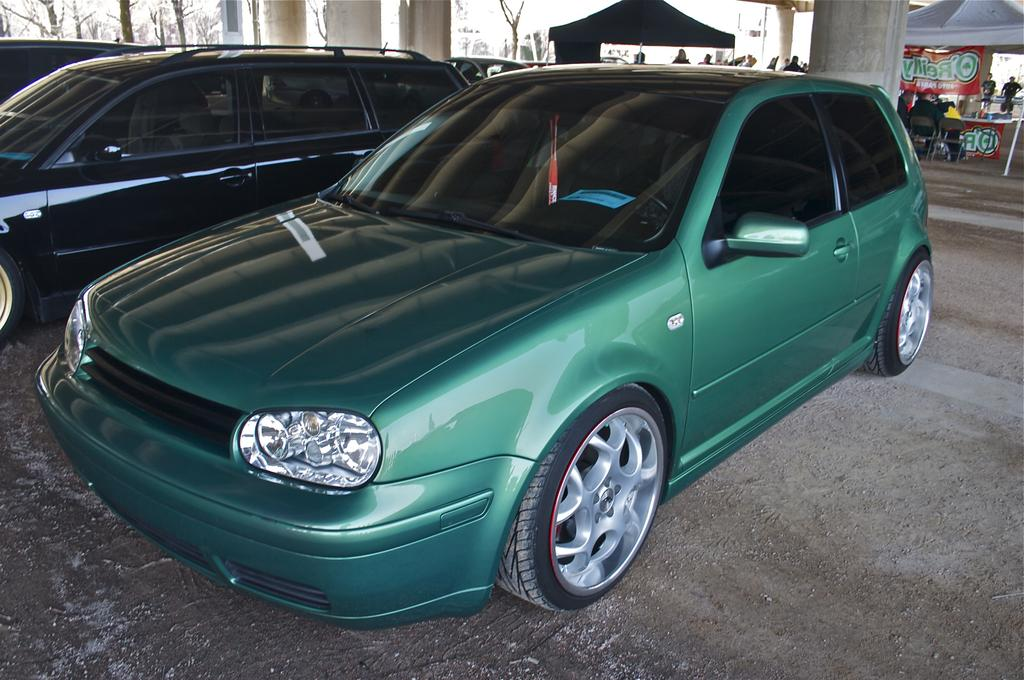What can be seen in the background of the image? In the background of the image, there are cars and tents. What are the people in the tents doing? The people sitting in the tents are likely resting or enjoying the outdoors. What architectural features are present in the image? There are pillars in the image. What year is depicted in the image? The provided facts do not mention any specific year, so it cannot be determined from the image. Can you identify any insects in the image? There are no insects visible in the image. 